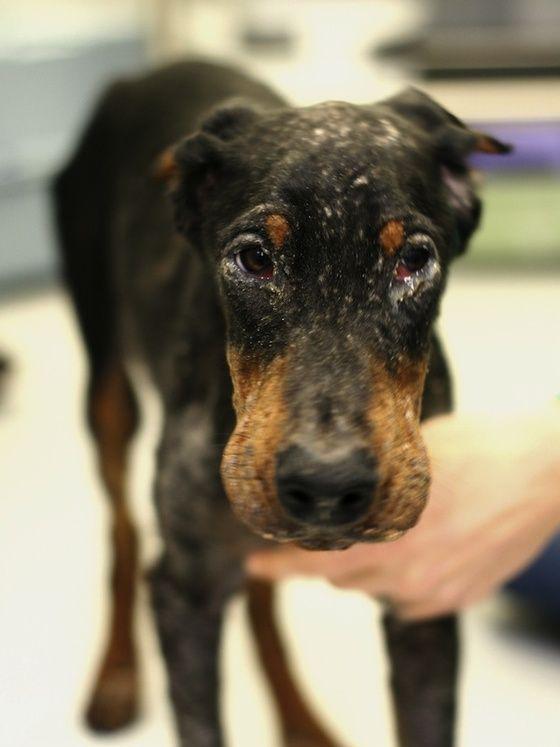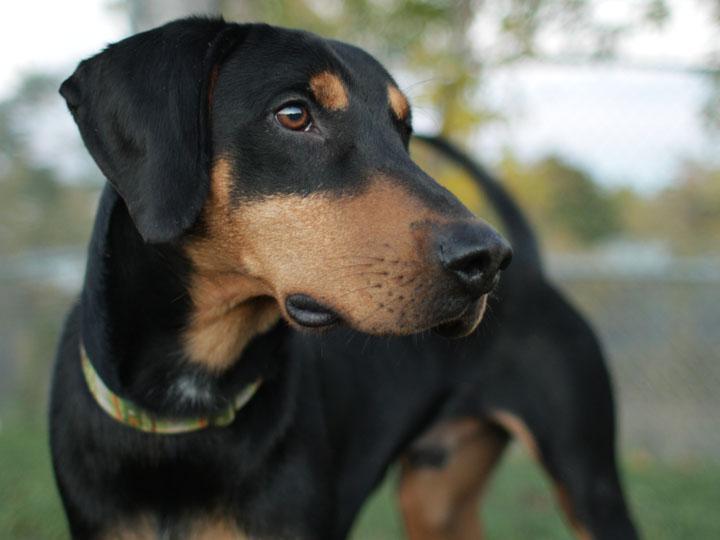The first image is the image on the left, the second image is the image on the right. For the images displayed, is the sentence "In at least one image there is a black and brown puppy with a heart tag on his collar, laying down." factually correct? Answer yes or no. No. The first image is the image on the left, the second image is the image on the right. Analyze the images presented: Is the assertion "One of the dogs is looking directly at the camera, and one of the dogs has an open mouth." valid? Answer yes or no. No. 